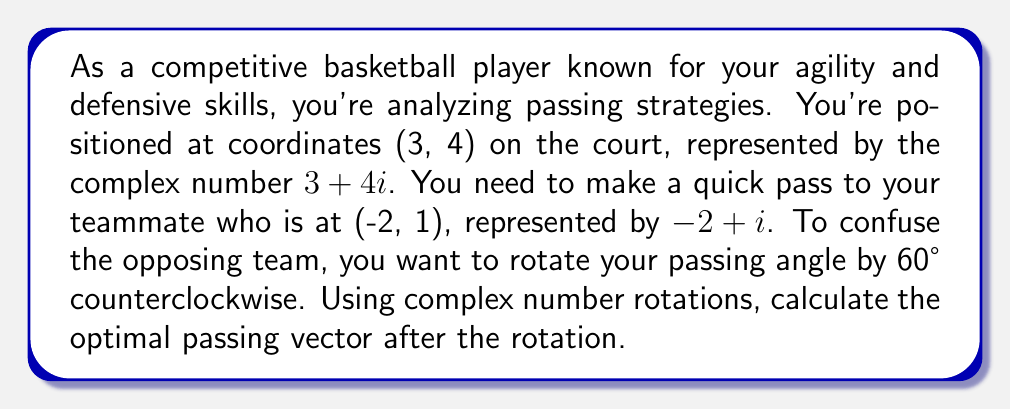Can you answer this question? Let's approach this step-by-step:

1) First, we need to find the initial passing vector. This is the difference between the teammate's position and your position:
   $(-2 + i) - (3 + 4i) = -5 - 3i$

2) To rotate a complex number by an angle $\theta$ counterclockwise, we multiply it by $e^{i\theta}$. For 60°, $\theta = \frac{\pi}{3}$ radians.

3) $e^{i\frac{\pi}{3}} = \cos(\frac{\pi}{3}) + i\sin(\frac{\pi}{3}) = \frac{1}{2} + i\frac{\sqrt{3}}{2}$

4) Now, we multiply our initial passing vector by this rotation factor:

   $$(-5 - 3i) * (\frac{1}{2} + i\frac{\sqrt{3}}{2})$$

5) Expanding this:
   $$(-\frac{5}{2} - \frac{3i}{2}) + (-\frac{5\sqrt{3}}{2}i + \frac{3\sqrt{3}}{2})$$

6) Combining real and imaginary parts:
   $$(-\frac{5}{2} + \frac{3\sqrt{3}}{2}) + (-\frac{5\sqrt{3}}{2} - \frac{3}{2})i$$

7) This can be simplified to:
   $$\frac{-5 + 3\sqrt{3}}{2} + \frac{-5\sqrt{3} - 3}{2}i$$

This is the optimal passing vector after rotation.
Answer: The optimal passing vector after rotation is $\frac{-5 + 3\sqrt{3}}{2} + \frac{-5\sqrt{3} - 3}{2}i$. 